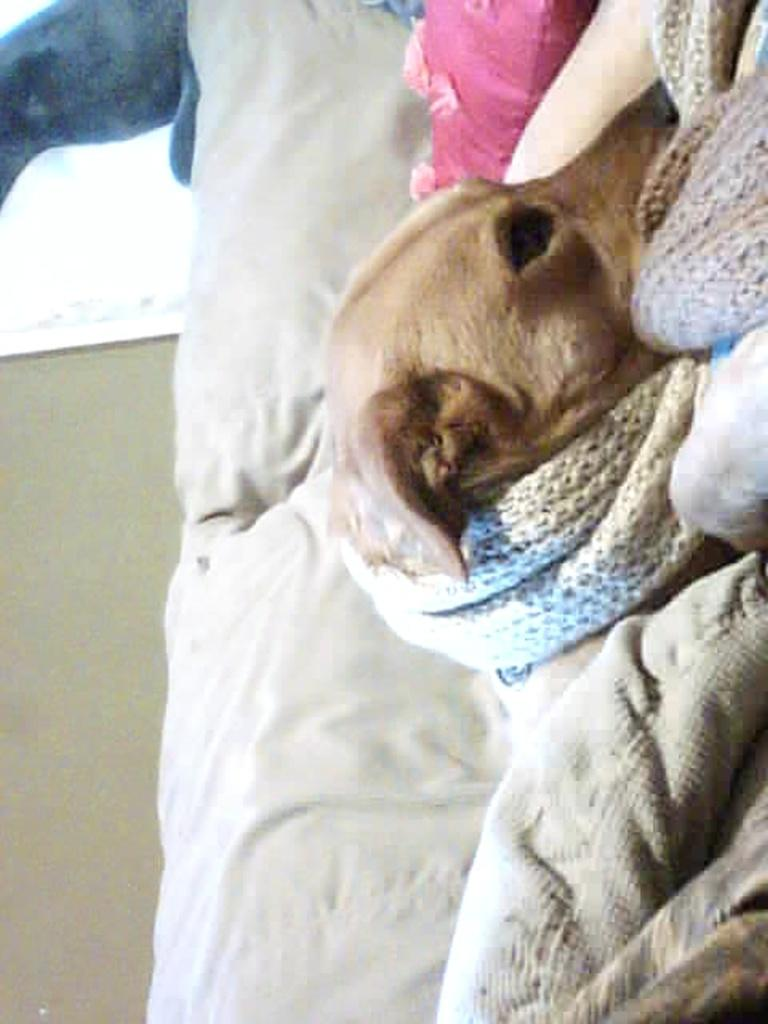What type of animal is in the image? There is a dog in the image. What color is the dog? The dog is in cream color. What is the dog sitting on? The dog is on a white cloth. What color is the background wall? The background wall is in cream color. How much sugar is on the dog's paw in the image? There is no sugar present in the image, and therefore no sugar can be found on the dog's paw. 